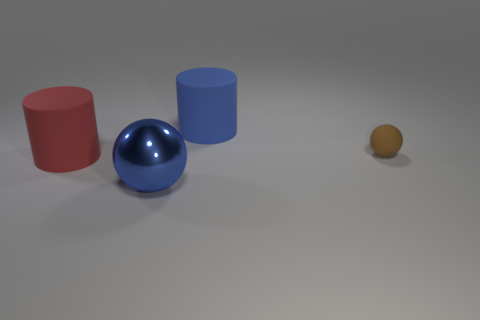What number of blocks are either blue objects or rubber objects?
Provide a succinct answer. 0. Is the number of balls that are behind the big blue ball the same as the number of small brown spheres that are behind the blue rubber object?
Offer a very short reply. No. How many blue balls are right of the sphere that is right of the sphere left of the tiny brown sphere?
Your answer should be compact. 0. There is a matte thing that is the same color as the metallic object; what is its shape?
Ensure brevity in your answer.  Cylinder. Do the shiny ball and the big object that is on the left side of the shiny object have the same color?
Offer a terse response. No. Is the number of metal things that are behind the blue shiny object greater than the number of cyan cylinders?
Offer a very short reply. No. How many things are large objects in front of the big blue cylinder or big blue objects to the right of the blue ball?
Keep it short and to the point. 3. What size is the blue cylinder that is the same material as the red cylinder?
Your response must be concise. Large. Is the shape of the large rubber thing that is behind the small rubber object the same as  the large red object?
Give a very brief answer. Yes. There is a matte cylinder that is the same color as the big metal sphere; what is its size?
Your answer should be compact. Large. 